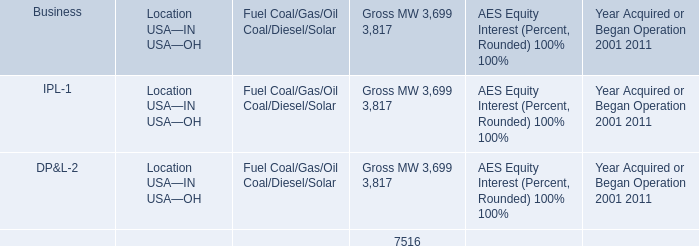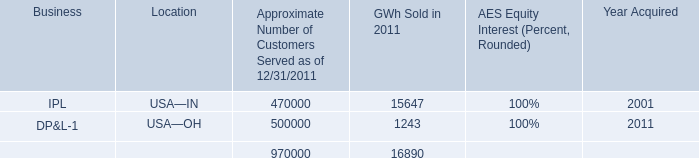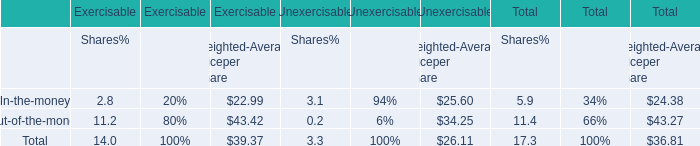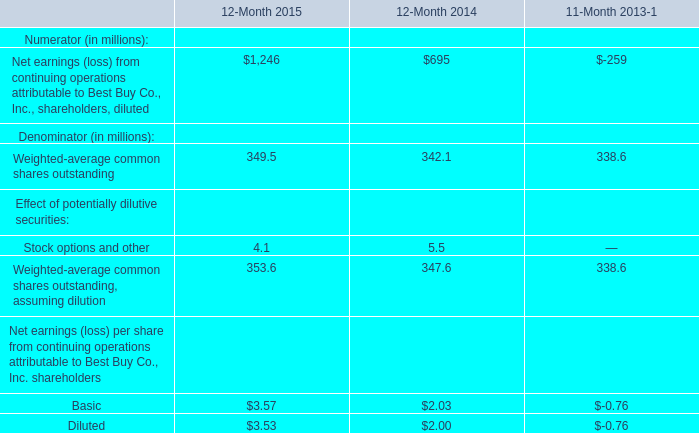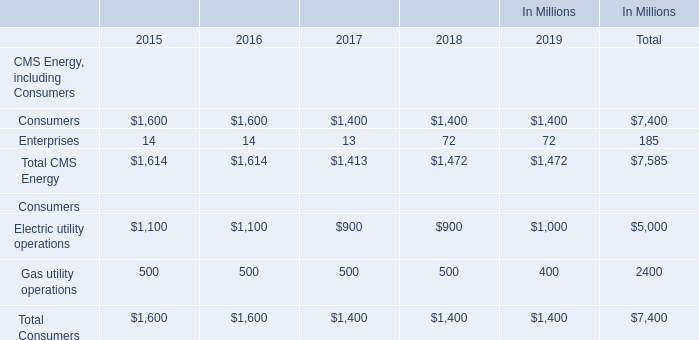How many kinds of CMS Energy( including Consumers) in 2019 are greater than those in the previous year? 
Answer: 1. 